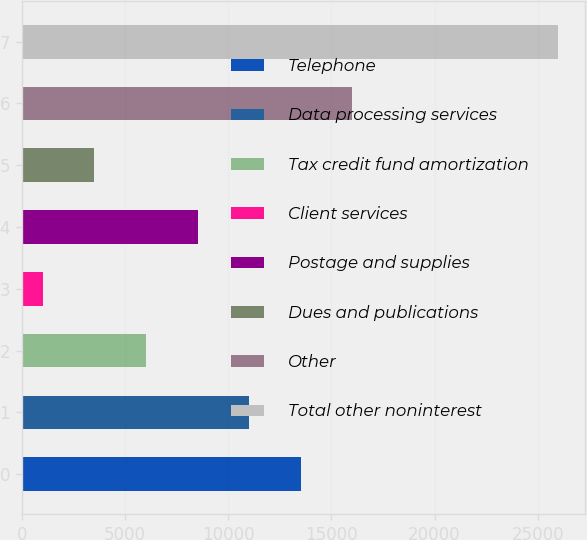Convert chart to OTSL. <chart><loc_0><loc_0><loc_500><loc_500><bar_chart><fcel>Telephone<fcel>Data processing services<fcel>Tax credit fund amortization<fcel>Client services<fcel>Postage and supplies<fcel>Dues and publications<fcel>Other<fcel>Total other noninterest<nl><fcel>13514.5<fcel>11016<fcel>6019<fcel>1022<fcel>8517.5<fcel>3520.5<fcel>16013<fcel>26007<nl></chart> 